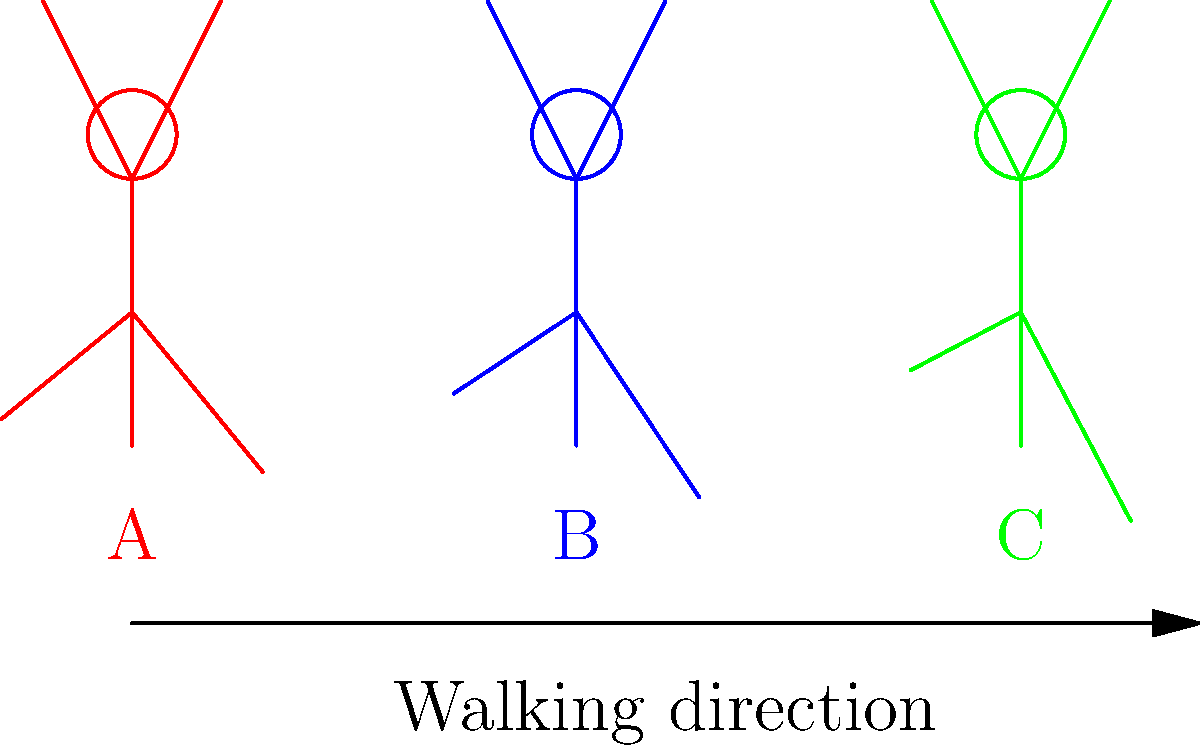The stick figure diagram shows three individuals (A, B, and C) with different walking gaits. Based on the leg positions, which individual is likely to have the highest walking speed, and how does this relate to step length and cadence in diverse populations? To answer this question, we need to analyze the biomechanics of walking gaits and their relationship to speed, step length, and cadence:

1. Leg angle and step length:
   - The angle between the legs indicates the step length.
   - A wider angle generally corresponds to a longer step.

2. Analyzing the diagram:
   - Figure A (red) has the smallest angle between legs.
   - Figure B (blue) has a medium angle.
   - Figure C (green) has the widest angle.

3. Relationship between step length and speed:
   - Longer steps often correlate with higher walking speeds.
   - $$\text{Walking speed} = \text{Step length} \times \text{Cadence}$$

4. Cadence consideration:
   - Cadence is the number of steps per minute.
   - Assuming similar cadence, the person with the longest step length will have the highest speed.

5. Diversity factors:
   - Different populations may have variations in average leg length and preferred walking speeds.
   - Cultural factors and environment can influence gait patterns.

6. Conclusion:
   - Figure C (green) has the widest leg angle, indicating the longest step length.
   - Assuming similar cadence across individuals, C is likely to have the highest walking speed.

This analysis demonstrates how diverse walking gaits can be studied using simple biomechanical principles, promoting an inclusive understanding of human movement patterns across different populations.
Answer: Figure C, due to the widest leg angle indicating longest step length. 